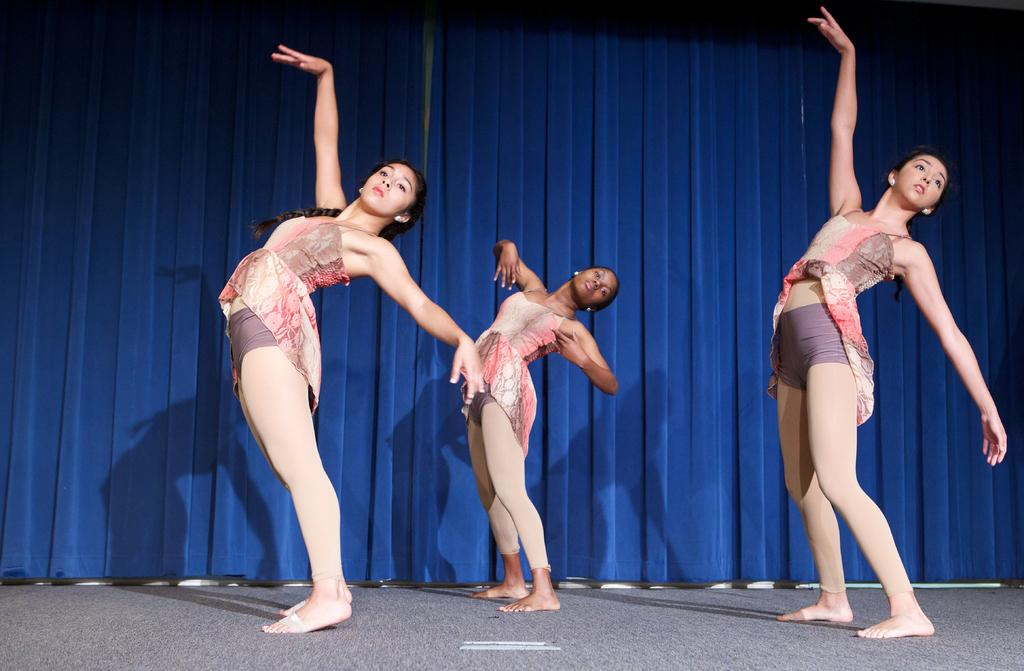How many women are present in the image? There are three women in the image. What are the women wearing? The women are wearing the same kind of costume. What activity are the women engaged in? The women are dancing on the floor. What can be seen in the background of the image? There is a curtain visible in the background of the image. What type of quartz can be seen on the floor during the women's dance performance? There is no quartz present in the image; the women are dancing on the floor without any visible quartz. 